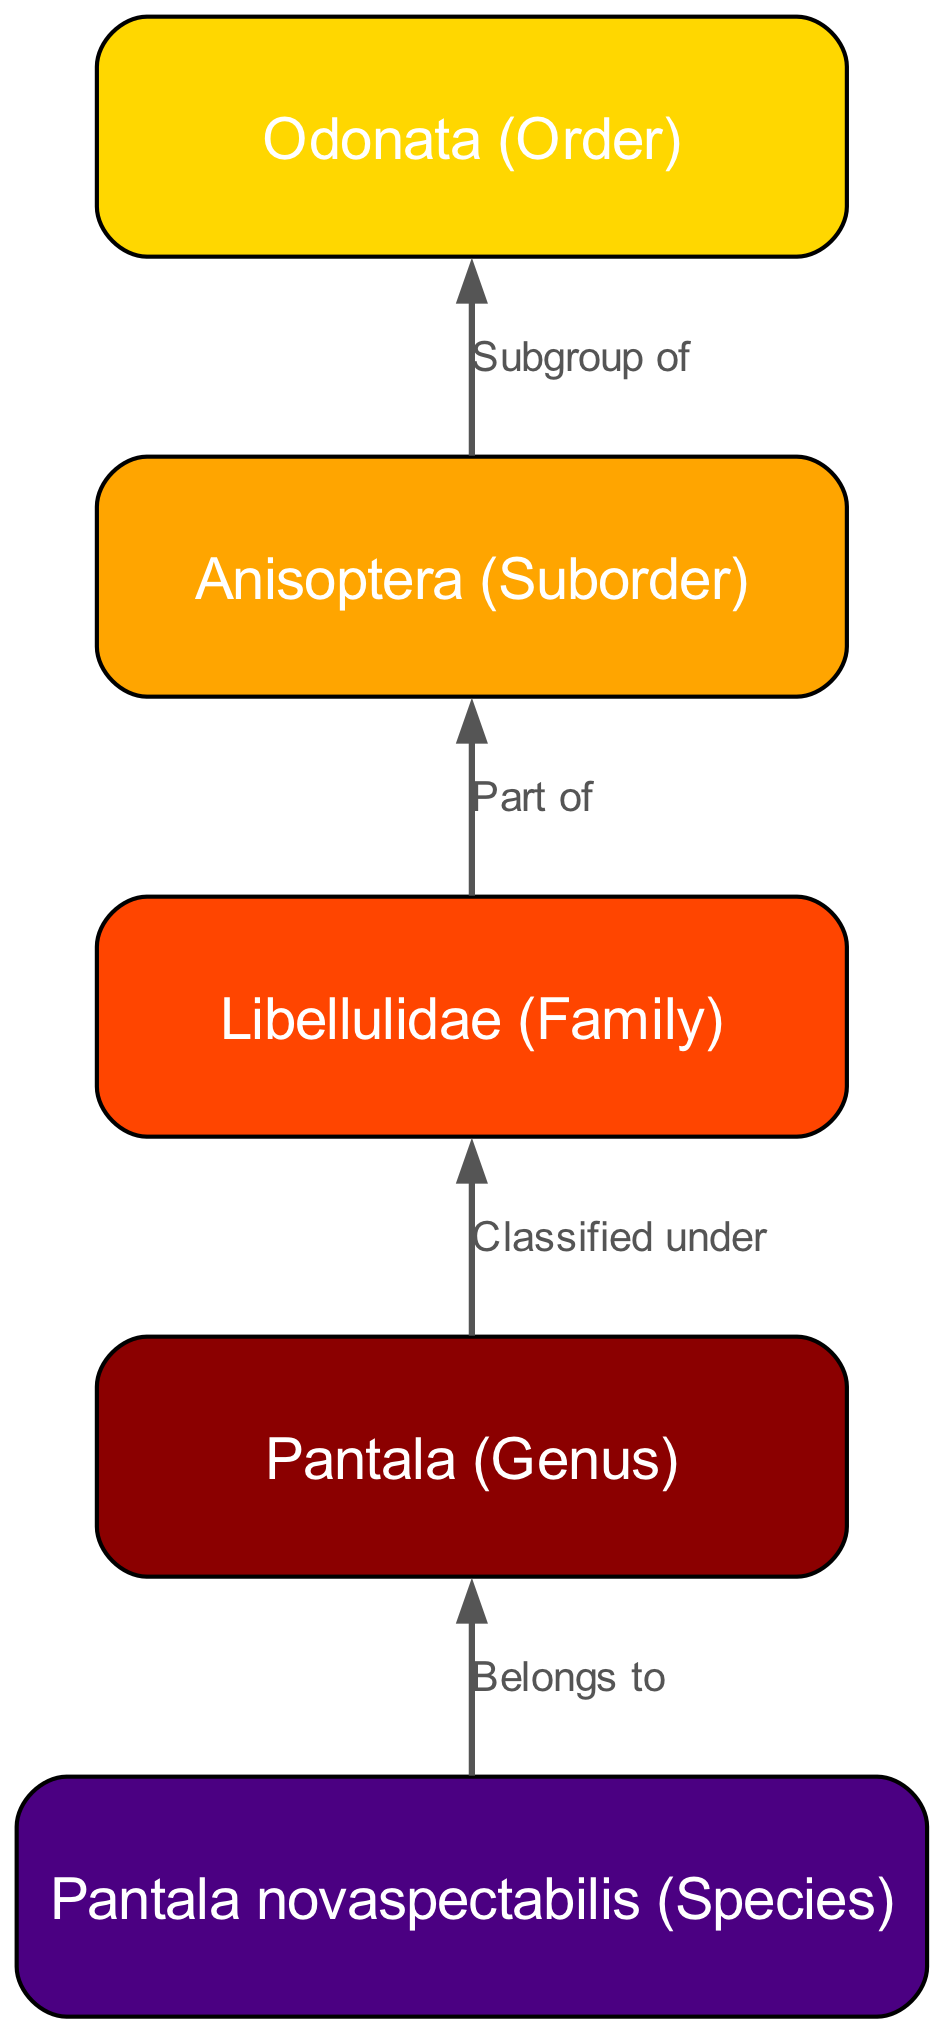What is the order of the newly identified dragonfly? The diagram indicates that the top-level classification of the dragonfly is "Odonata." The order is represented at the highest point in the flowchart, confirming it as the order to which this dragonfly belongs.
Answer: Odonata How many nodes are present in the diagram? By counting the listed classifications, there are 5 distinct nodes in the diagram, each representing different taxonomic ranks within the classification hierarchy of the dragonfly.
Answer: 5 What family does Pantala belong to? The diagram shows that Pantala is classified under the family Libellulidae. This relationship is indicated through an edge connecting Pantala and Libellulidae.
Answer: Libellulidae What is the species of the newly identified dragonfly? The species name is provided directly in the last node of the diagram, which states "Pantala novaspectabilis." This node represents the specific species within the genus Pantala.
Answer: Pantala novaspectabilis What is the relationship between Pantala and Libellulidae? The diagram indicates that Pantala is classified under the family Libellulidae. This demonstrates a direct relationship in the taxonomic hierarchy from genus to family.
Answer: Classified under Explain the path from species to order in terms of classifications. Starting from the species "Pantala novaspectabilis," we trace the hierarchy upward: it belongs to the genus Pantala, which is classified under the family Libellulidae. The family is part of the suborder Anisoptera, which is a subgroup of the order Odonata. This sequential flow represents how each classification leads to the next higher level.
Answer: Pantala novaspectabilis > Pantala > Libellulidae > Anisoptera > Odonata How does the suborder relate to the order? The diagram specifies that the suborder Anisoptera is a subgroup of the order Odonata. This establishes a direct relationship where Anisoptera falls under the broader classification of Odonata in the taxonomic hierarchy.
Answer: Subgroup of Which node represents the genus in the hierarchy? The diagram clearly identifies the node labeled "Pantala" as the genus of the newly identified dragonfly. This is positioned just above the species node and below the family node, fitting the expected structure of taxonomic classification.
Answer: Pantala How many edges connect the nodes in the diagram? The diagram presents 4 distinct edges that connect the nodes, indicating the relationships between the different taxonomic ranks from species up to order. Each edge reflects a hierarchical classification link.
Answer: 4 